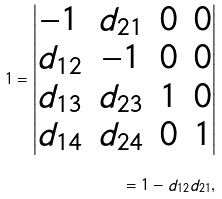<formula> <loc_0><loc_0><loc_500><loc_500>1 = \begin{vmatrix} - 1 & d _ { 2 1 } & 0 & 0 \\ d _ { 1 2 } & - 1 & 0 & 0 \\ d _ { 1 3 } & d _ { 2 3 } & 1 & 0 \\ d _ { 1 4 } & d _ { 2 4 } & 0 & 1 \\ \end{vmatrix} \\ = 1 - d _ { 1 2 } d _ { 2 1 } ,</formula> 